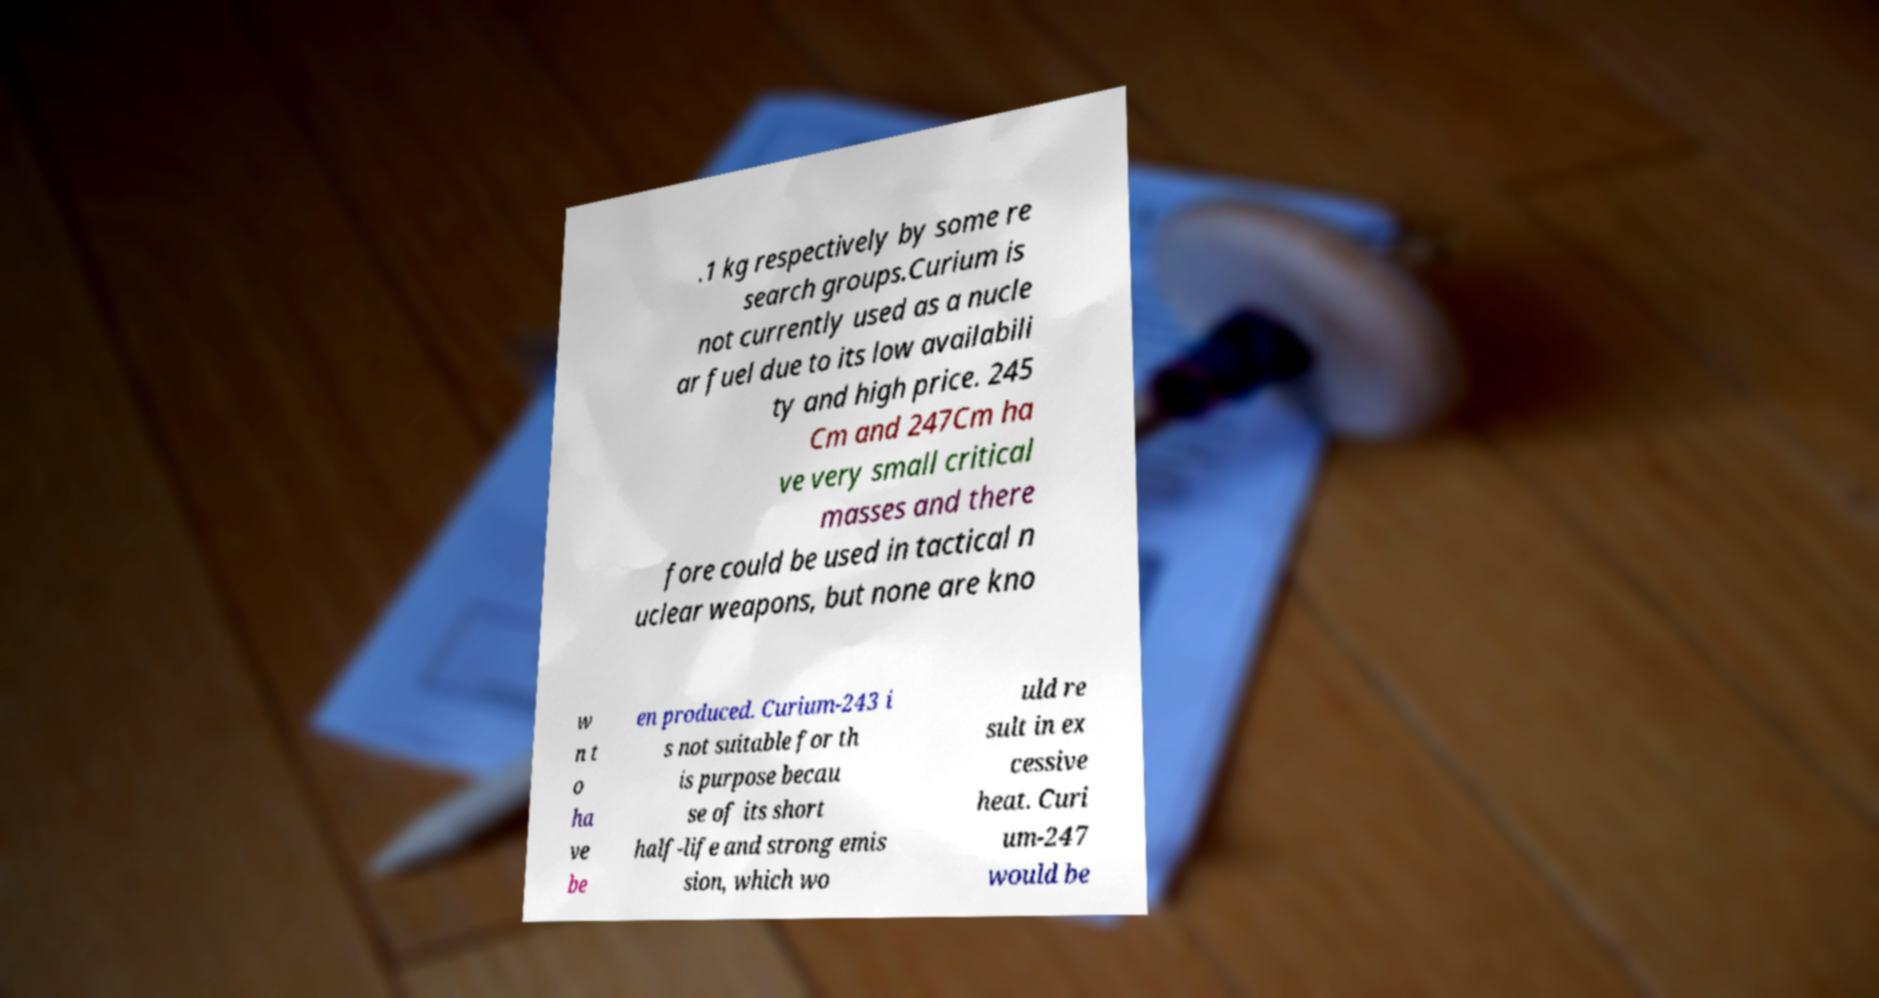What messages or text are displayed in this image? I need them in a readable, typed format. .1 kg respectively by some re search groups.Curium is not currently used as a nucle ar fuel due to its low availabili ty and high price. 245 Cm and 247Cm ha ve very small critical masses and there fore could be used in tactical n uclear weapons, but none are kno w n t o ha ve be en produced. Curium-243 i s not suitable for th is purpose becau se of its short half-life and strong emis sion, which wo uld re sult in ex cessive heat. Curi um-247 would be 